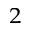<formula> <loc_0><loc_0><loc_500><loc_500>_ { 2 }</formula> 